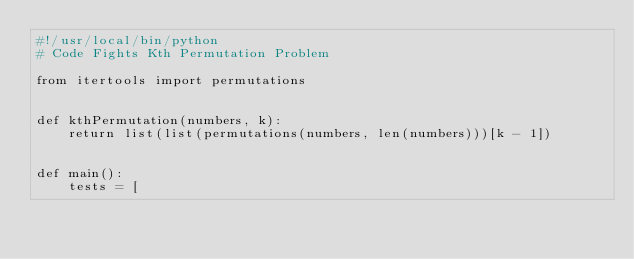Convert code to text. <code><loc_0><loc_0><loc_500><loc_500><_Python_>#!/usr/local/bin/python
# Code Fights Kth Permutation Problem

from itertools import permutations


def kthPermutation(numbers, k):
    return list(list(permutations(numbers, len(numbers)))[k - 1])


def main():
    tests = [</code> 